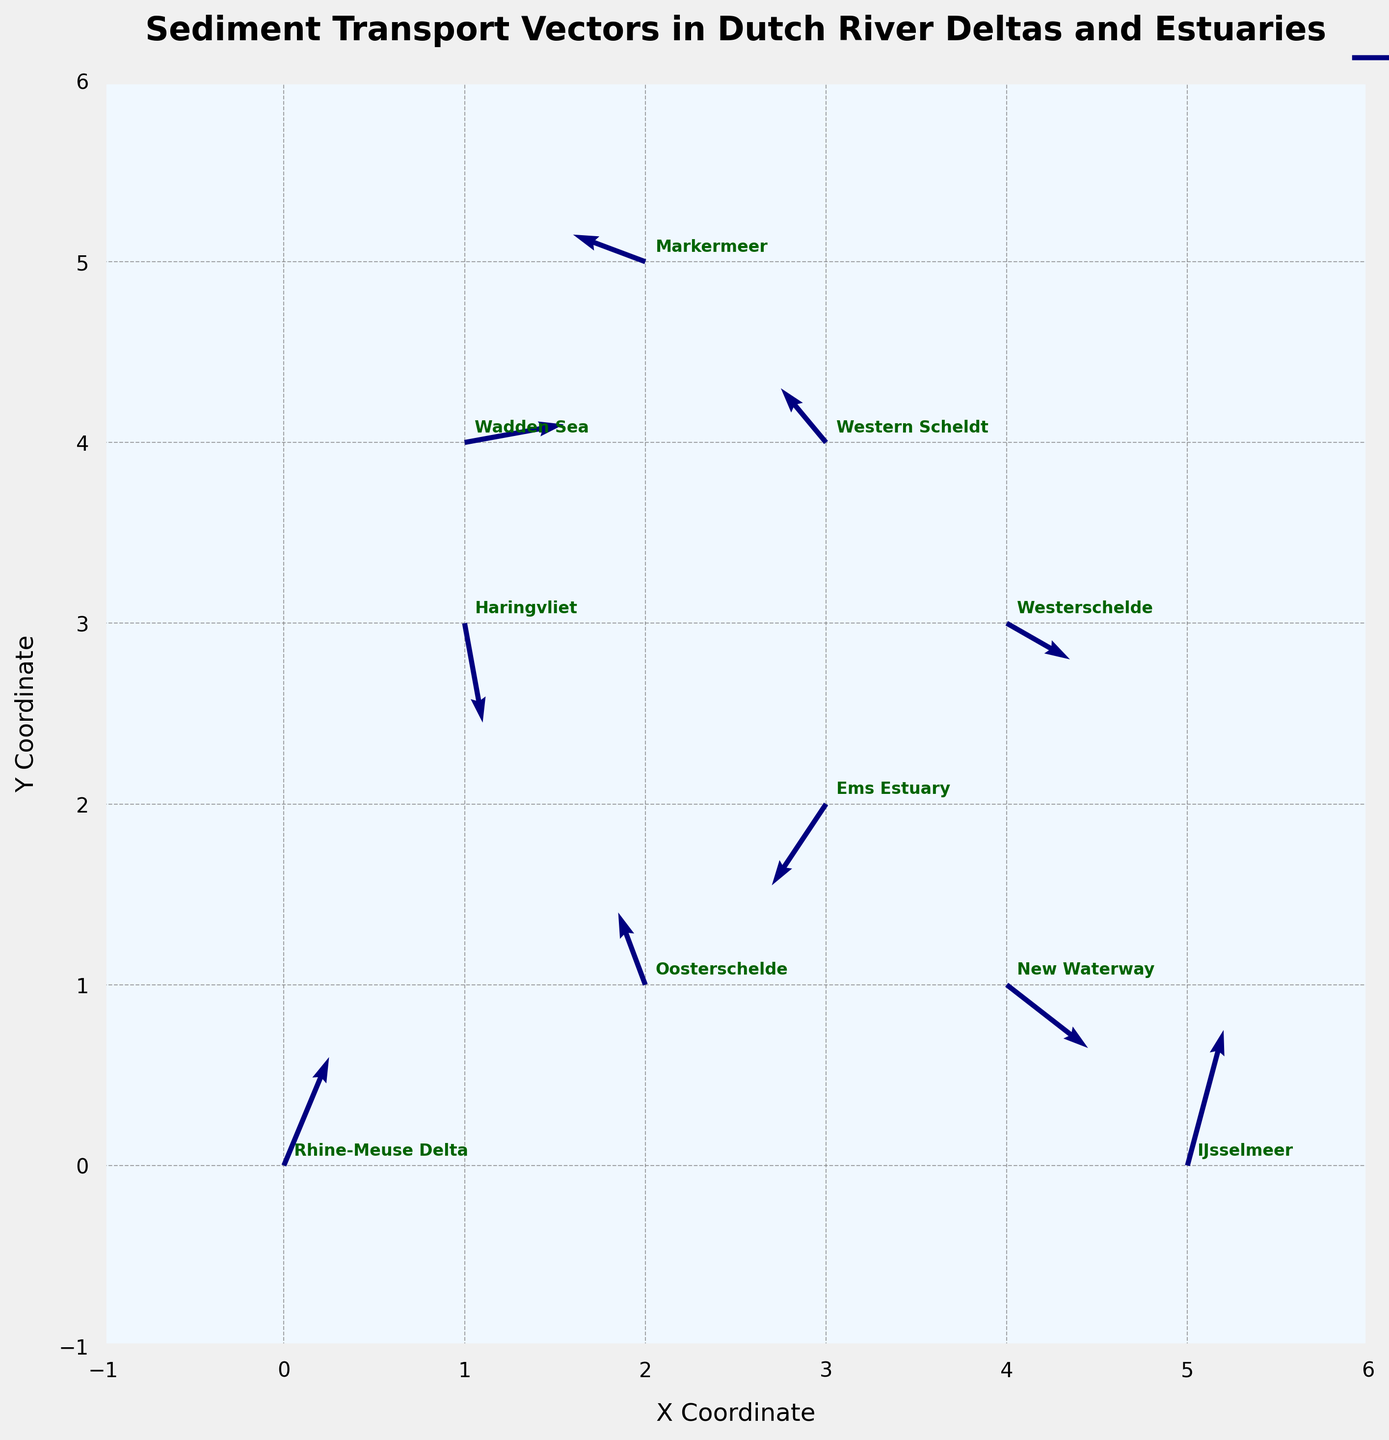What is the title of the plot? The title of the plot is displayed at the top of the figure. It reads "Sediment Transport Vectors in Dutch River Deltas and Estuaries".
Answer: Sediment Transport Vectors in Dutch River Deltas and Estuaries What are the coordinates of the point representing the Wadden Sea? Look for the label "Wadden Sea" on the plot and note its coordinates. The label is placed near the coordinates (1, 4). This is derived from the data where x=1 and y=4 for the Wadden Sea.
Answer: (1, 4) Which location has the longest vector? Compare the lengths of all vectors. The length of a vector can be calculated as the square root of the sum of the squares of its components (u^2 + v^2). The location with the largest value will be the one with the longest vector. The IJsselmeer has vector components u=0.4 and v=1.5, giving a length of sqrt(0.4^2 + 1.5^2) ≈ 1.55, which is the longest among the others.
Answer: IJsselmeer How many locations have vectors pointing in the negative x-direction? Identify the vectors with a negative u-component. From the data, the locations with negative u-components are Oosterschelde (-0.3), Ems Estuary (-0.6), Markermeer (-0.8), and Western Scheldt (-0.5). This totals to four locations.
Answer: 4 What is the vector direction for the Haringvliet? Look for the vector associated with Haringvliet. The vector components are u=0.2 and v=-1.1. This indicates the vector points primarily downward (negative y-direction) with a slight rightward (positive x-direction) component.
Answer: Primarily downward with a slight rightward component Compare the vector lengths of the New Waterway and the Western Scheldt. Which one is longer? Calculate the lengths of both vectors. New Waterway: sqrt(0.9^2 + (-0.7)^2) ≈ 1.14. Western Scheldt: sqrt((-0.5)^2 + 0.6^2) ≈ 0.78. Therefore, the New Waterway has a longer vector compared to Western Scheldt.
Answer: New Waterway Which vector has the sharpest upward direction and what location does it represent? To determine sharp upward direction, find the vector with the highest positive v-component. The vectors and their v-component are compared, and IJsselmeer with v=1.5 has the highest upward direction.
Answer: IJsselmeer What is the vector magnitude difference between Westerschelde and Rhine-Meuse Delta? Calculate the magnitudes of both vectors. For Westerschelde: sqrt(0.7^2 + (-0.4)^2) ≈ 0.81. For Rhine-Meuse Delta: sqrt(0.5^2 + 1.2^2) ≈ 1.3. The difference is approximately 1.3 - 0.81 = 0.49.
Answer: 0.49 Is there any location where the vector points directly downward (negative y-direction only)? Look for vectors with a u-component of 0 and a negative v-component. None of the provided vectors fit this description.
Answer: No 